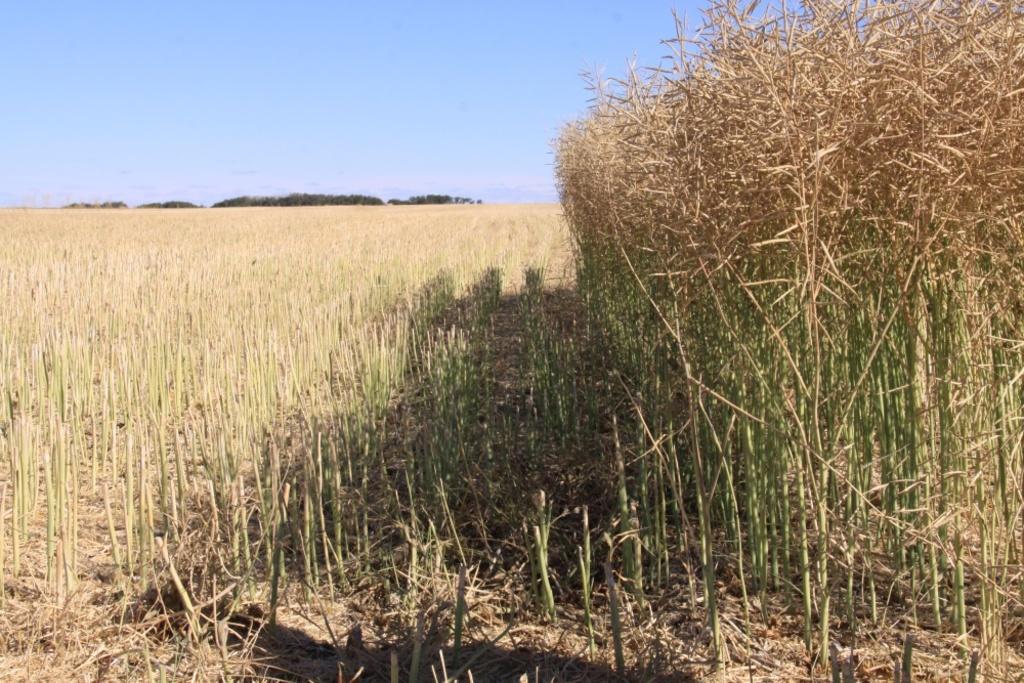Could you give a brief overview of what you see in this image? In this picture I can see some plants. 